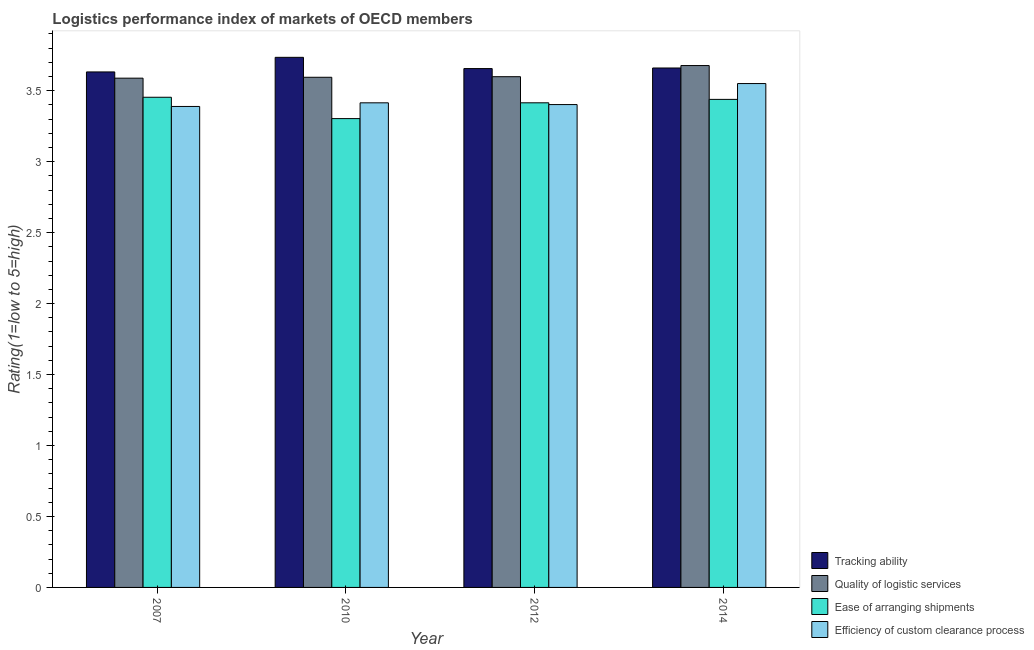Are the number of bars per tick equal to the number of legend labels?
Make the answer very short. Yes. Are the number of bars on each tick of the X-axis equal?
Your answer should be very brief. Yes. How many bars are there on the 4th tick from the left?
Provide a succinct answer. 4. How many bars are there on the 2nd tick from the right?
Provide a short and direct response. 4. What is the label of the 1st group of bars from the left?
Keep it short and to the point. 2007. What is the lpi rating of quality of logistic services in 2010?
Provide a succinct answer. 3.6. Across all years, what is the maximum lpi rating of efficiency of custom clearance process?
Offer a terse response. 3.55. Across all years, what is the minimum lpi rating of quality of logistic services?
Your response must be concise. 3.59. In which year was the lpi rating of quality of logistic services minimum?
Keep it short and to the point. 2007. What is the total lpi rating of quality of logistic services in the graph?
Ensure brevity in your answer.  14.46. What is the difference between the lpi rating of quality of logistic services in 2007 and that in 2010?
Provide a succinct answer. -0.01. What is the difference between the lpi rating of tracking ability in 2010 and the lpi rating of quality of logistic services in 2007?
Make the answer very short. 0.1. What is the average lpi rating of quality of logistic services per year?
Give a very brief answer. 3.62. What is the ratio of the lpi rating of efficiency of custom clearance process in 2007 to that in 2010?
Provide a succinct answer. 0.99. What is the difference between the highest and the second highest lpi rating of quality of logistic services?
Keep it short and to the point. 0.08. What is the difference between the highest and the lowest lpi rating of efficiency of custom clearance process?
Your answer should be compact. 0.16. What does the 2nd bar from the left in 2014 represents?
Give a very brief answer. Quality of logistic services. What does the 4th bar from the right in 2012 represents?
Give a very brief answer. Tracking ability. Is it the case that in every year, the sum of the lpi rating of tracking ability and lpi rating of quality of logistic services is greater than the lpi rating of ease of arranging shipments?
Your answer should be compact. Yes. How many bars are there?
Provide a succinct answer. 16. Are all the bars in the graph horizontal?
Your answer should be very brief. No. How many years are there in the graph?
Your answer should be compact. 4. What is the difference between two consecutive major ticks on the Y-axis?
Provide a short and direct response. 0.5. Are the values on the major ticks of Y-axis written in scientific E-notation?
Offer a very short reply. No. Does the graph contain grids?
Offer a terse response. No. Where does the legend appear in the graph?
Give a very brief answer. Bottom right. How many legend labels are there?
Offer a terse response. 4. What is the title of the graph?
Give a very brief answer. Logistics performance index of markets of OECD members. Does "Goods and services" appear as one of the legend labels in the graph?
Offer a terse response. No. What is the label or title of the Y-axis?
Your response must be concise. Rating(1=low to 5=high). What is the Rating(1=low to 5=high) of Tracking ability in 2007?
Give a very brief answer. 3.63. What is the Rating(1=low to 5=high) of Quality of logistic services in 2007?
Keep it short and to the point. 3.59. What is the Rating(1=low to 5=high) of Ease of arranging shipments in 2007?
Your answer should be compact. 3.45. What is the Rating(1=low to 5=high) of Efficiency of custom clearance process in 2007?
Give a very brief answer. 3.39. What is the Rating(1=low to 5=high) of Tracking ability in 2010?
Your response must be concise. 3.74. What is the Rating(1=low to 5=high) of Quality of logistic services in 2010?
Keep it short and to the point. 3.6. What is the Rating(1=low to 5=high) in Ease of arranging shipments in 2010?
Provide a succinct answer. 3.3. What is the Rating(1=low to 5=high) in Efficiency of custom clearance process in 2010?
Provide a succinct answer. 3.42. What is the Rating(1=low to 5=high) in Tracking ability in 2012?
Offer a very short reply. 3.66. What is the Rating(1=low to 5=high) in Quality of logistic services in 2012?
Offer a terse response. 3.6. What is the Rating(1=low to 5=high) in Ease of arranging shipments in 2012?
Your response must be concise. 3.42. What is the Rating(1=low to 5=high) in Efficiency of custom clearance process in 2012?
Your response must be concise. 3.4. What is the Rating(1=low to 5=high) in Tracking ability in 2014?
Provide a succinct answer. 3.66. What is the Rating(1=low to 5=high) in Quality of logistic services in 2014?
Your answer should be compact. 3.68. What is the Rating(1=low to 5=high) of Ease of arranging shipments in 2014?
Provide a succinct answer. 3.44. What is the Rating(1=low to 5=high) of Efficiency of custom clearance process in 2014?
Keep it short and to the point. 3.55. Across all years, what is the maximum Rating(1=low to 5=high) in Tracking ability?
Provide a succinct answer. 3.74. Across all years, what is the maximum Rating(1=low to 5=high) in Quality of logistic services?
Ensure brevity in your answer.  3.68. Across all years, what is the maximum Rating(1=low to 5=high) in Ease of arranging shipments?
Ensure brevity in your answer.  3.45. Across all years, what is the maximum Rating(1=low to 5=high) in Efficiency of custom clearance process?
Your answer should be compact. 3.55. Across all years, what is the minimum Rating(1=low to 5=high) in Tracking ability?
Make the answer very short. 3.63. Across all years, what is the minimum Rating(1=low to 5=high) in Quality of logistic services?
Provide a short and direct response. 3.59. Across all years, what is the minimum Rating(1=low to 5=high) of Ease of arranging shipments?
Provide a succinct answer. 3.3. Across all years, what is the minimum Rating(1=low to 5=high) of Efficiency of custom clearance process?
Offer a terse response. 3.39. What is the total Rating(1=low to 5=high) in Tracking ability in the graph?
Provide a short and direct response. 14.69. What is the total Rating(1=low to 5=high) of Quality of logistic services in the graph?
Keep it short and to the point. 14.46. What is the total Rating(1=low to 5=high) of Ease of arranging shipments in the graph?
Offer a very short reply. 13.61. What is the total Rating(1=low to 5=high) in Efficiency of custom clearance process in the graph?
Offer a terse response. 13.76. What is the difference between the Rating(1=low to 5=high) in Tracking ability in 2007 and that in 2010?
Your answer should be very brief. -0.1. What is the difference between the Rating(1=low to 5=high) in Quality of logistic services in 2007 and that in 2010?
Ensure brevity in your answer.  -0.01. What is the difference between the Rating(1=low to 5=high) in Ease of arranging shipments in 2007 and that in 2010?
Keep it short and to the point. 0.15. What is the difference between the Rating(1=low to 5=high) of Efficiency of custom clearance process in 2007 and that in 2010?
Provide a succinct answer. -0.03. What is the difference between the Rating(1=low to 5=high) of Tracking ability in 2007 and that in 2012?
Make the answer very short. -0.02. What is the difference between the Rating(1=low to 5=high) of Quality of logistic services in 2007 and that in 2012?
Your response must be concise. -0.01. What is the difference between the Rating(1=low to 5=high) of Ease of arranging shipments in 2007 and that in 2012?
Your answer should be compact. 0.04. What is the difference between the Rating(1=low to 5=high) in Efficiency of custom clearance process in 2007 and that in 2012?
Your answer should be very brief. -0.01. What is the difference between the Rating(1=low to 5=high) of Tracking ability in 2007 and that in 2014?
Provide a succinct answer. -0.03. What is the difference between the Rating(1=low to 5=high) of Quality of logistic services in 2007 and that in 2014?
Keep it short and to the point. -0.09. What is the difference between the Rating(1=low to 5=high) of Ease of arranging shipments in 2007 and that in 2014?
Offer a very short reply. 0.01. What is the difference between the Rating(1=low to 5=high) in Efficiency of custom clearance process in 2007 and that in 2014?
Your response must be concise. -0.16. What is the difference between the Rating(1=low to 5=high) of Tracking ability in 2010 and that in 2012?
Your response must be concise. 0.08. What is the difference between the Rating(1=low to 5=high) of Quality of logistic services in 2010 and that in 2012?
Ensure brevity in your answer.  -0. What is the difference between the Rating(1=low to 5=high) of Ease of arranging shipments in 2010 and that in 2012?
Provide a succinct answer. -0.11. What is the difference between the Rating(1=low to 5=high) in Efficiency of custom clearance process in 2010 and that in 2012?
Offer a very short reply. 0.01. What is the difference between the Rating(1=low to 5=high) of Tracking ability in 2010 and that in 2014?
Offer a very short reply. 0.08. What is the difference between the Rating(1=low to 5=high) in Quality of logistic services in 2010 and that in 2014?
Offer a terse response. -0.08. What is the difference between the Rating(1=low to 5=high) of Ease of arranging shipments in 2010 and that in 2014?
Provide a short and direct response. -0.14. What is the difference between the Rating(1=low to 5=high) of Efficiency of custom clearance process in 2010 and that in 2014?
Give a very brief answer. -0.14. What is the difference between the Rating(1=low to 5=high) in Tracking ability in 2012 and that in 2014?
Provide a short and direct response. -0. What is the difference between the Rating(1=low to 5=high) in Quality of logistic services in 2012 and that in 2014?
Provide a short and direct response. -0.08. What is the difference between the Rating(1=low to 5=high) of Ease of arranging shipments in 2012 and that in 2014?
Ensure brevity in your answer.  -0.02. What is the difference between the Rating(1=low to 5=high) of Efficiency of custom clearance process in 2012 and that in 2014?
Keep it short and to the point. -0.15. What is the difference between the Rating(1=low to 5=high) of Tracking ability in 2007 and the Rating(1=low to 5=high) of Quality of logistic services in 2010?
Provide a succinct answer. 0.04. What is the difference between the Rating(1=low to 5=high) in Tracking ability in 2007 and the Rating(1=low to 5=high) in Ease of arranging shipments in 2010?
Make the answer very short. 0.33. What is the difference between the Rating(1=low to 5=high) in Tracking ability in 2007 and the Rating(1=low to 5=high) in Efficiency of custom clearance process in 2010?
Offer a very short reply. 0.22. What is the difference between the Rating(1=low to 5=high) in Quality of logistic services in 2007 and the Rating(1=low to 5=high) in Ease of arranging shipments in 2010?
Give a very brief answer. 0.28. What is the difference between the Rating(1=low to 5=high) of Quality of logistic services in 2007 and the Rating(1=low to 5=high) of Efficiency of custom clearance process in 2010?
Your response must be concise. 0.17. What is the difference between the Rating(1=low to 5=high) in Ease of arranging shipments in 2007 and the Rating(1=low to 5=high) in Efficiency of custom clearance process in 2010?
Your response must be concise. 0.04. What is the difference between the Rating(1=low to 5=high) in Tracking ability in 2007 and the Rating(1=low to 5=high) in Quality of logistic services in 2012?
Your answer should be very brief. 0.03. What is the difference between the Rating(1=low to 5=high) in Tracking ability in 2007 and the Rating(1=low to 5=high) in Ease of arranging shipments in 2012?
Offer a terse response. 0.22. What is the difference between the Rating(1=low to 5=high) of Tracking ability in 2007 and the Rating(1=low to 5=high) of Efficiency of custom clearance process in 2012?
Offer a very short reply. 0.23. What is the difference between the Rating(1=low to 5=high) in Quality of logistic services in 2007 and the Rating(1=low to 5=high) in Ease of arranging shipments in 2012?
Provide a succinct answer. 0.17. What is the difference between the Rating(1=low to 5=high) in Quality of logistic services in 2007 and the Rating(1=low to 5=high) in Efficiency of custom clearance process in 2012?
Keep it short and to the point. 0.19. What is the difference between the Rating(1=low to 5=high) of Ease of arranging shipments in 2007 and the Rating(1=low to 5=high) of Efficiency of custom clearance process in 2012?
Provide a short and direct response. 0.05. What is the difference between the Rating(1=low to 5=high) of Tracking ability in 2007 and the Rating(1=low to 5=high) of Quality of logistic services in 2014?
Make the answer very short. -0.04. What is the difference between the Rating(1=low to 5=high) in Tracking ability in 2007 and the Rating(1=low to 5=high) in Ease of arranging shipments in 2014?
Your answer should be very brief. 0.19. What is the difference between the Rating(1=low to 5=high) in Tracking ability in 2007 and the Rating(1=low to 5=high) in Efficiency of custom clearance process in 2014?
Provide a short and direct response. 0.08. What is the difference between the Rating(1=low to 5=high) of Quality of logistic services in 2007 and the Rating(1=low to 5=high) of Ease of arranging shipments in 2014?
Provide a short and direct response. 0.15. What is the difference between the Rating(1=low to 5=high) of Quality of logistic services in 2007 and the Rating(1=low to 5=high) of Efficiency of custom clearance process in 2014?
Ensure brevity in your answer.  0.04. What is the difference between the Rating(1=low to 5=high) in Ease of arranging shipments in 2007 and the Rating(1=low to 5=high) in Efficiency of custom clearance process in 2014?
Ensure brevity in your answer.  -0.1. What is the difference between the Rating(1=low to 5=high) of Tracking ability in 2010 and the Rating(1=low to 5=high) of Quality of logistic services in 2012?
Provide a short and direct response. 0.14. What is the difference between the Rating(1=low to 5=high) of Tracking ability in 2010 and the Rating(1=low to 5=high) of Ease of arranging shipments in 2012?
Offer a very short reply. 0.32. What is the difference between the Rating(1=low to 5=high) of Tracking ability in 2010 and the Rating(1=low to 5=high) of Efficiency of custom clearance process in 2012?
Make the answer very short. 0.33. What is the difference between the Rating(1=low to 5=high) of Quality of logistic services in 2010 and the Rating(1=low to 5=high) of Ease of arranging shipments in 2012?
Provide a short and direct response. 0.18. What is the difference between the Rating(1=low to 5=high) in Quality of logistic services in 2010 and the Rating(1=low to 5=high) in Efficiency of custom clearance process in 2012?
Your answer should be very brief. 0.19. What is the difference between the Rating(1=low to 5=high) of Ease of arranging shipments in 2010 and the Rating(1=low to 5=high) of Efficiency of custom clearance process in 2012?
Offer a very short reply. -0.1. What is the difference between the Rating(1=low to 5=high) in Tracking ability in 2010 and the Rating(1=low to 5=high) in Quality of logistic services in 2014?
Offer a very short reply. 0.06. What is the difference between the Rating(1=low to 5=high) in Tracking ability in 2010 and the Rating(1=low to 5=high) in Ease of arranging shipments in 2014?
Your answer should be very brief. 0.3. What is the difference between the Rating(1=low to 5=high) in Tracking ability in 2010 and the Rating(1=low to 5=high) in Efficiency of custom clearance process in 2014?
Ensure brevity in your answer.  0.18. What is the difference between the Rating(1=low to 5=high) in Quality of logistic services in 2010 and the Rating(1=low to 5=high) in Ease of arranging shipments in 2014?
Keep it short and to the point. 0.16. What is the difference between the Rating(1=low to 5=high) of Quality of logistic services in 2010 and the Rating(1=low to 5=high) of Efficiency of custom clearance process in 2014?
Offer a very short reply. 0.04. What is the difference between the Rating(1=low to 5=high) in Ease of arranging shipments in 2010 and the Rating(1=low to 5=high) in Efficiency of custom clearance process in 2014?
Offer a very short reply. -0.25. What is the difference between the Rating(1=low to 5=high) in Tracking ability in 2012 and the Rating(1=low to 5=high) in Quality of logistic services in 2014?
Ensure brevity in your answer.  -0.02. What is the difference between the Rating(1=low to 5=high) in Tracking ability in 2012 and the Rating(1=low to 5=high) in Ease of arranging shipments in 2014?
Make the answer very short. 0.22. What is the difference between the Rating(1=low to 5=high) in Tracking ability in 2012 and the Rating(1=low to 5=high) in Efficiency of custom clearance process in 2014?
Your answer should be compact. 0.11. What is the difference between the Rating(1=low to 5=high) of Quality of logistic services in 2012 and the Rating(1=low to 5=high) of Ease of arranging shipments in 2014?
Make the answer very short. 0.16. What is the difference between the Rating(1=low to 5=high) of Quality of logistic services in 2012 and the Rating(1=low to 5=high) of Efficiency of custom clearance process in 2014?
Your answer should be very brief. 0.05. What is the difference between the Rating(1=low to 5=high) in Ease of arranging shipments in 2012 and the Rating(1=low to 5=high) in Efficiency of custom clearance process in 2014?
Make the answer very short. -0.14. What is the average Rating(1=low to 5=high) in Tracking ability per year?
Give a very brief answer. 3.67. What is the average Rating(1=low to 5=high) of Quality of logistic services per year?
Keep it short and to the point. 3.62. What is the average Rating(1=low to 5=high) in Ease of arranging shipments per year?
Ensure brevity in your answer.  3.4. What is the average Rating(1=low to 5=high) of Efficiency of custom clearance process per year?
Provide a succinct answer. 3.44. In the year 2007, what is the difference between the Rating(1=low to 5=high) of Tracking ability and Rating(1=low to 5=high) of Quality of logistic services?
Give a very brief answer. 0.04. In the year 2007, what is the difference between the Rating(1=low to 5=high) in Tracking ability and Rating(1=low to 5=high) in Ease of arranging shipments?
Your response must be concise. 0.18. In the year 2007, what is the difference between the Rating(1=low to 5=high) of Tracking ability and Rating(1=low to 5=high) of Efficiency of custom clearance process?
Your response must be concise. 0.24. In the year 2007, what is the difference between the Rating(1=low to 5=high) of Quality of logistic services and Rating(1=low to 5=high) of Ease of arranging shipments?
Provide a succinct answer. 0.13. In the year 2007, what is the difference between the Rating(1=low to 5=high) of Quality of logistic services and Rating(1=low to 5=high) of Efficiency of custom clearance process?
Provide a succinct answer. 0.2. In the year 2007, what is the difference between the Rating(1=low to 5=high) of Ease of arranging shipments and Rating(1=low to 5=high) of Efficiency of custom clearance process?
Give a very brief answer. 0.06. In the year 2010, what is the difference between the Rating(1=low to 5=high) in Tracking ability and Rating(1=low to 5=high) in Quality of logistic services?
Make the answer very short. 0.14. In the year 2010, what is the difference between the Rating(1=low to 5=high) of Tracking ability and Rating(1=low to 5=high) of Ease of arranging shipments?
Provide a short and direct response. 0.43. In the year 2010, what is the difference between the Rating(1=low to 5=high) in Tracking ability and Rating(1=low to 5=high) in Efficiency of custom clearance process?
Ensure brevity in your answer.  0.32. In the year 2010, what is the difference between the Rating(1=low to 5=high) in Quality of logistic services and Rating(1=low to 5=high) in Ease of arranging shipments?
Keep it short and to the point. 0.29. In the year 2010, what is the difference between the Rating(1=low to 5=high) in Quality of logistic services and Rating(1=low to 5=high) in Efficiency of custom clearance process?
Make the answer very short. 0.18. In the year 2010, what is the difference between the Rating(1=low to 5=high) in Ease of arranging shipments and Rating(1=low to 5=high) in Efficiency of custom clearance process?
Your answer should be very brief. -0.11. In the year 2012, what is the difference between the Rating(1=low to 5=high) in Tracking ability and Rating(1=low to 5=high) in Quality of logistic services?
Give a very brief answer. 0.06. In the year 2012, what is the difference between the Rating(1=low to 5=high) in Tracking ability and Rating(1=low to 5=high) in Ease of arranging shipments?
Offer a very short reply. 0.24. In the year 2012, what is the difference between the Rating(1=low to 5=high) in Tracking ability and Rating(1=low to 5=high) in Efficiency of custom clearance process?
Give a very brief answer. 0.25. In the year 2012, what is the difference between the Rating(1=low to 5=high) of Quality of logistic services and Rating(1=low to 5=high) of Ease of arranging shipments?
Ensure brevity in your answer.  0.18. In the year 2012, what is the difference between the Rating(1=low to 5=high) in Quality of logistic services and Rating(1=low to 5=high) in Efficiency of custom clearance process?
Give a very brief answer. 0.2. In the year 2012, what is the difference between the Rating(1=low to 5=high) of Ease of arranging shipments and Rating(1=low to 5=high) of Efficiency of custom clearance process?
Give a very brief answer. 0.01. In the year 2014, what is the difference between the Rating(1=low to 5=high) in Tracking ability and Rating(1=low to 5=high) in Quality of logistic services?
Keep it short and to the point. -0.02. In the year 2014, what is the difference between the Rating(1=low to 5=high) of Tracking ability and Rating(1=low to 5=high) of Ease of arranging shipments?
Ensure brevity in your answer.  0.22. In the year 2014, what is the difference between the Rating(1=low to 5=high) in Tracking ability and Rating(1=low to 5=high) in Efficiency of custom clearance process?
Offer a very short reply. 0.11. In the year 2014, what is the difference between the Rating(1=low to 5=high) in Quality of logistic services and Rating(1=low to 5=high) in Ease of arranging shipments?
Make the answer very short. 0.24. In the year 2014, what is the difference between the Rating(1=low to 5=high) of Quality of logistic services and Rating(1=low to 5=high) of Efficiency of custom clearance process?
Make the answer very short. 0.13. In the year 2014, what is the difference between the Rating(1=low to 5=high) of Ease of arranging shipments and Rating(1=low to 5=high) of Efficiency of custom clearance process?
Your answer should be very brief. -0.11. What is the ratio of the Rating(1=low to 5=high) of Tracking ability in 2007 to that in 2010?
Offer a very short reply. 0.97. What is the ratio of the Rating(1=low to 5=high) in Quality of logistic services in 2007 to that in 2010?
Provide a short and direct response. 1. What is the ratio of the Rating(1=low to 5=high) in Ease of arranging shipments in 2007 to that in 2010?
Give a very brief answer. 1.05. What is the ratio of the Rating(1=low to 5=high) of Quality of logistic services in 2007 to that in 2012?
Ensure brevity in your answer.  1. What is the ratio of the Rating(1=low to 5=high) of Ease of arranging shipments in 2007 to that in 2012?
Give a very brief answer. 1.01. What is the ratio of the Rating(1=low to 5=high) of Efficiency of custom clearance process in 2007 to that in 2012?
Give a very brief answer. 1. What is the ratio of the Rating(1=low to 5=high) of Tracking ability in 2007 to that in 2014?
Keep it short and to the point. 0.99. What is the ratio of the Rating(1=low to 5=high) in Quality of logistic services in 2007 to that in 2014?
Your answer should be very brief. 0.98. What is the ratio of the Rating(1=low to 5=high) in Ease of arranging shipments in 2007 to that in 2014?
Your answer should be compact. 1. What is the ratio of the Rating(1=low to 5=high) of Efficiency of custom clearance process in 2007 to that in 2014?
Ensure brevity in your answer.  0.95. What is the ratio of the Rating(1=low to 5=high) of Tracking ability in 2010 to that in 2012?
Your answer should be very brief. 1.02. What is the ratio of the Rating(1=low to 5=high) of Quality of logistic services in 2010 to that in 2012?
Provide a succinct answer. 1. What is the ratio of the Rating(1=low to 5=high) of Ease of arranging shipments in 2010 to that in 2012?
Offer a very short reply. 0.97. What is the ratio of the Rating(1=low to 5=high) in Tracking ability in 2010 to that in 2014?
Provide a succinct answer. 1.02. What is the ratio of the Rating(1=low to 5=high) of Quality of logistic services in 2010 to that in 2014?
Ensure brevity in your answer.  0.98. What is the ratio of the Rating(1=low to 5=high) in Ease of arranging shipments in 2010 to that in 2014?
Keep it short and to the point. 0.96. What is the ratio of the Rating(1=low to 5=high) of Efficiency of custom clearance process in 2010 to that in 2014?
Give a very brief answer. 0.96. What is the ratio of the Rating(1=low to 5=high) of Tracking ability in 2012 to that in 2014?
Provide a succinct answer. 1. What is the ratio of the Rating(1=low to 5=high) of Quality of logistic services in 2012 to that in 2014?
Offer a terse response. 0.98. What is the ratio of the Rating(1=low to 5=high) in Efficiency of custom clearance process in 2012 to that in 2014?
Your response must be concise. 0.96. What is the difference between the highest and the second highest Rating(1=low to 5=high) in Tracking ability?
Provide a short and direct response. 0.08. What is the difference between the highest and the second highest Rating(1=low to 5=high) of Quality of logistic services?
Offer a terse response. 0.08. What is the difference between the highest and the second highest Rating(1=low to 5=high) in Ease of arranging shipments?
Provide a short and direct response. 0.01. What is the difference between the highest and the second highest Rating(1=low to 5=high) of Efficiency of custom clearance process?
Ensure brevity in your answer.  0.14. What is the difference between the highest and the lowest Rating(1=low to 5=high) in Tracking ability?
Offer a terse response. 0.1. What is the difference between the highest and the lowest Rating(1=low to 5=high) of Quality of logistic services?
Keep it short and to the point. 0.09. What is the difference between the highest and the lowest Rating(1=low to 5=high) of Ease of arranging shipments?
Give a very brief answer. 0.15. What is the difference between the highest and the lowest Rating(1=low to 5=high) in Efficiency of custom clearance process?
Provide a short and direct response. 0.16. 